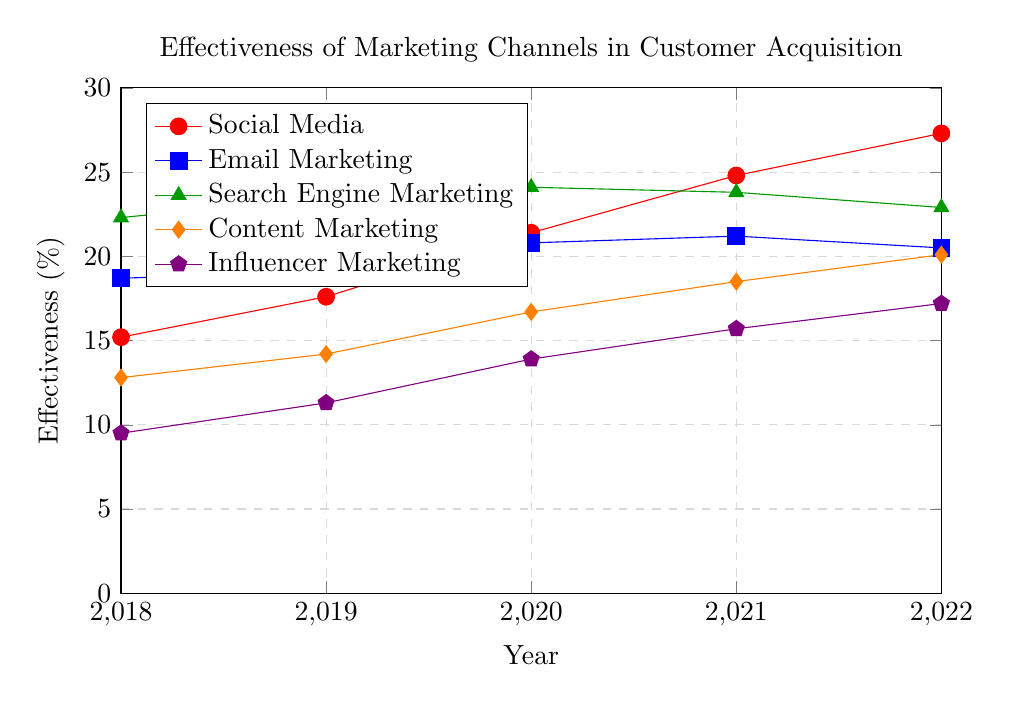Which marketing channel showed the highest effectiveness in customer acquisition in 2022? The 2022 data shows the highest value for Social Media effectiveness, so Social Media is the channel with the highest effectiveness in customer acquisition in 2022.
Answer: Social Media What is the total increase in effectiveness of Content Marketing from 2018 to 2022? The effectiveness of Content Marketing in 2018 was 12.8%, and in 2022 it was 20.1%. To find the total increase: 20.1 - 12.8 = 7.3
Answer: 7.3% Between which two consecutive years did Influencer Marketing show the largest increase in effectiveness? Looking at the yearly data for Influencer Marketing: 2018 to 2019 shows an increase of 1.8%, 2019 to 2020 shows an increase of 2.6%, 2020 to 2021 shows an increase of 1.8%, and 2021 to 2022 shows an increase of 1.5%. The largest increase is between 2019 and 2020.
Answer: 2019 to 2020 Did any marketing channel show a decrease in effectiveness from 2021 to 2022? If so, which one? Comparing data from 2021 to 2022, Email Marketing decreased from 21.2% to 20.5%.
Answer: Email Marketing Which marketing channel consistently showed an upward trend in effectiveness over the period from 2018 to 2022? Reviewing the trends: Social Media, Content Marketing, and Influencer Marketing all showed consistent increases every year.
Answer: Social Media, Content Marketing, and Influencer Marketing What was the average effectiveness of Email Marketing over the 5-year period? Sum up the effectiveness values for Email Marketing: 18.7 + 19.1 + 20.8 + 21.2 + 20.5 = 100.3. Divide by 5 years: 100.3 / 5 = 20.06
Answer: 20.06% How did the effectiveness of Search Engine Marketing in 2022 compare to its effectiveness in 2020? The effectiveness of Search Engine Marketing was 24.1% in 2020 and 22.9% in 2022. The difference is 22.9 - 24.1 = -1.2, showing a decrease.
Answer: Decreased by 1.2% Which marketing channel had the lowest effectiveness in 2018, and how did its effectiveness change by 2022? Influencer Marketing had the lowest effectiveness in 2018 at 9.5%. In 2022, its effectiveness was 17.2%. The change is: 17.2 - 9.5 = 7.7
Answer: Influencer Marketing increased by 7.7% Which year saw the biggest increase in the effectiveness of Social Media marketing? Analyzing yearly differences: 2018 to 2019 is 2.4%, 2019 to 2020 is 3.8%, 2020 to 2021 is 3.4%, 2021 to 2022 is 2.5%. The largest increase is between 2019 and 2020.
Answer: 2019 to 2020 